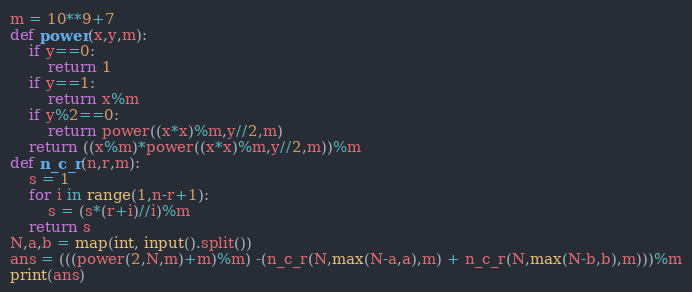<code> <loc_0><loc_0><loc_500><loc_500><_Python_>m = 10**9+7
def power(x,y,m):
    if y==0:
        return 1
    if y==1:
        return x%m
    if y%2==0:
        return power((x*x)%m,y//2,m)
    return ((x%m)*power((x*x)%m,y//2,m))%m
def n_c_r(n,r,m):
  	s = 1
    for i in range(1,n-r+1):
      	s = (s*(r+i)//i)%m
    return s
N,a,b = map(int, input().split())
ans = (((power(2,N,m)+m)%m) -(n_c_r(N,max(N-a,a),m) + n_c_r(N,max(N-b,b),m)))%m
print(ans)</code> 